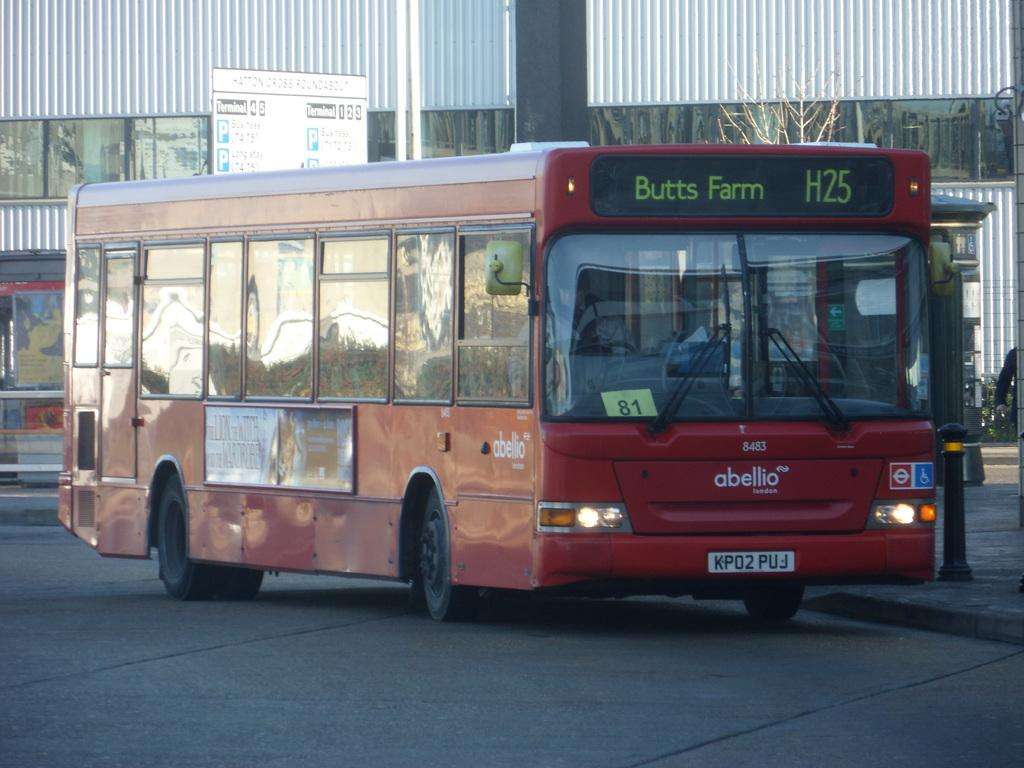What color is the vehicle in the image? The vehicle in the image is red. What can be seen in the background of the image? There is a board visible in the background. What type of structures are present in the image? There are stalls in the image. How would you describe the color scheme of the building in the background? The building in the background is white and gray. How many kittens are playing on the roof of the stalls in the image? There are no kittens present in the image. What type of tools might a carpenter be using in the image? There is no carpenter or tools present in the image. 